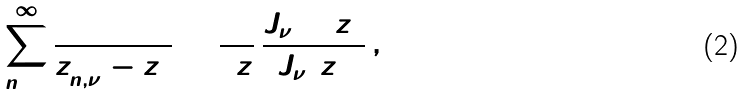<formula> <loc_0><loc_0><loc_500><loc_500>\sum _ { n = 1 } ^ { \infty } \frac { 1 } { z _ { n , \nu } ^ { 2 } - z ^ { 2 } } = \frac { 1 } { 2 z } \, \frac { J _ { \nu + 1 } ( z ) } { J _ { \nu } ( z ) } \, ,</formula> 